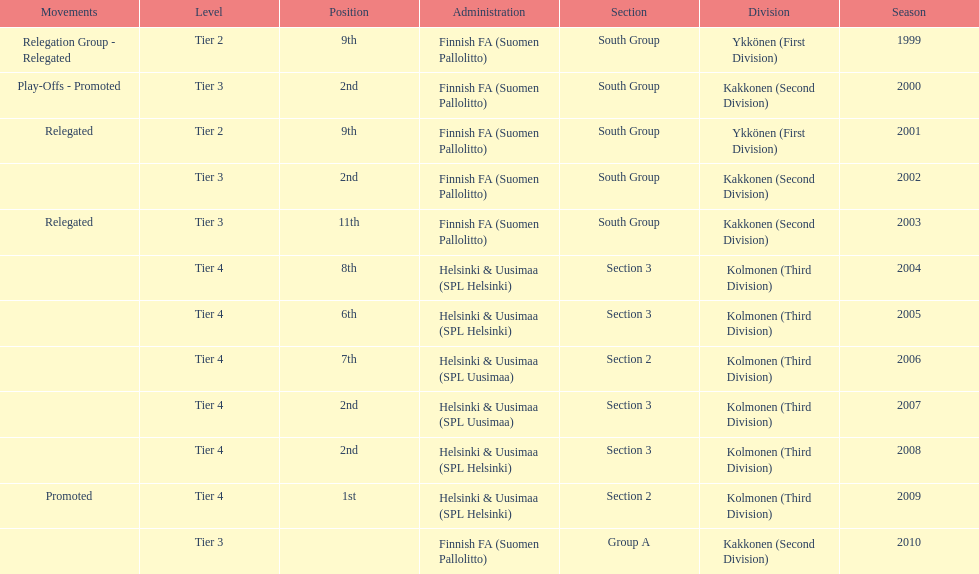What position did this team get after getting 9th place in 1999? 2nd. 